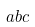Convert formula to latex. <formula><loc_0><loc_0><loc_500><loc_500>a b c</formula> 